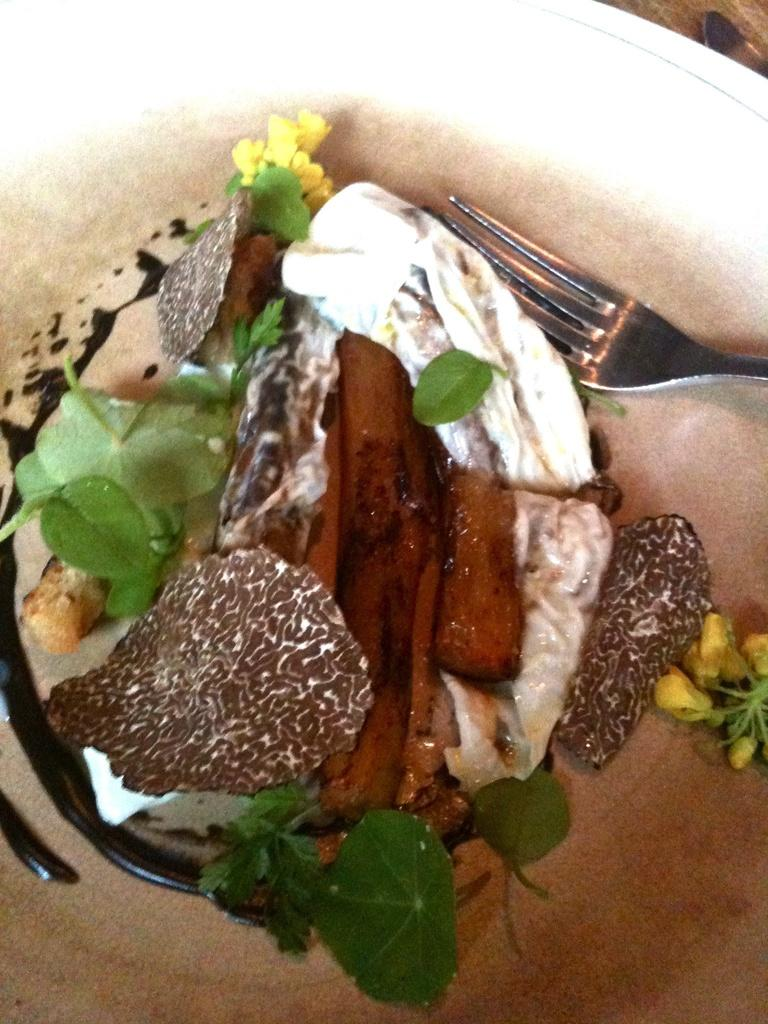What is in the bowl that is visible in the picture? There is a bowl in the picture, and it contains ice cream. What color is the bowl? The bowl is white in color. What additional detail can be observed about the ice cream? The ice cream has leaf garnish. What utensil is present in the bowl? There is a fork in the bowl. What type of degree is the ice cream pursuing in the image? The ice cream is not pursuing a degree in the image, as it is a dessert and not a sentient being capable of pursuing higher education. 